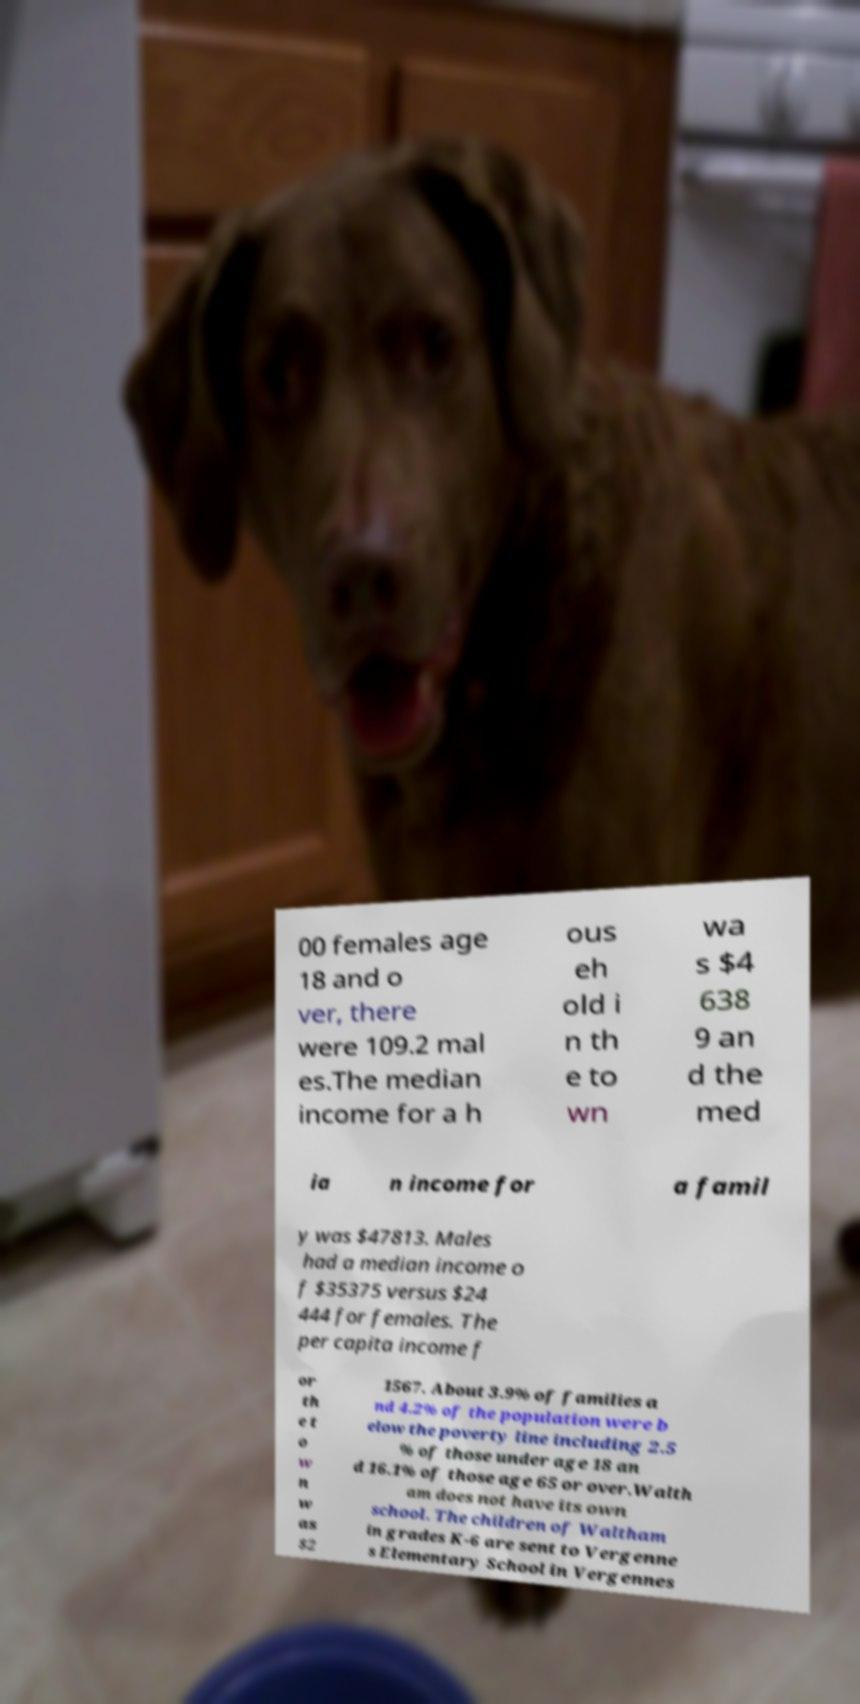Could you extract and type out the text from this image? 00 females age 18 and o ver, there were 109.2 mal es.The median income for a h ous eh old i n th e to wn wa s $4 638 9 an d the med ia n income for a famil y was $47813. Males had a median income o f $35375 versus $24 444 for females. The per capita income f or th e t o w n w as $2 1567. About 3.9% of families a nd 4.2% of the population were b elow the poverty line including 2.5 % of those under age 18 an d 16.1% of those age 65 or over.Walth am does not have its own school. The children of Waltham in grades K-6 are sent to Vergenne s Elementary School in Vergennes 